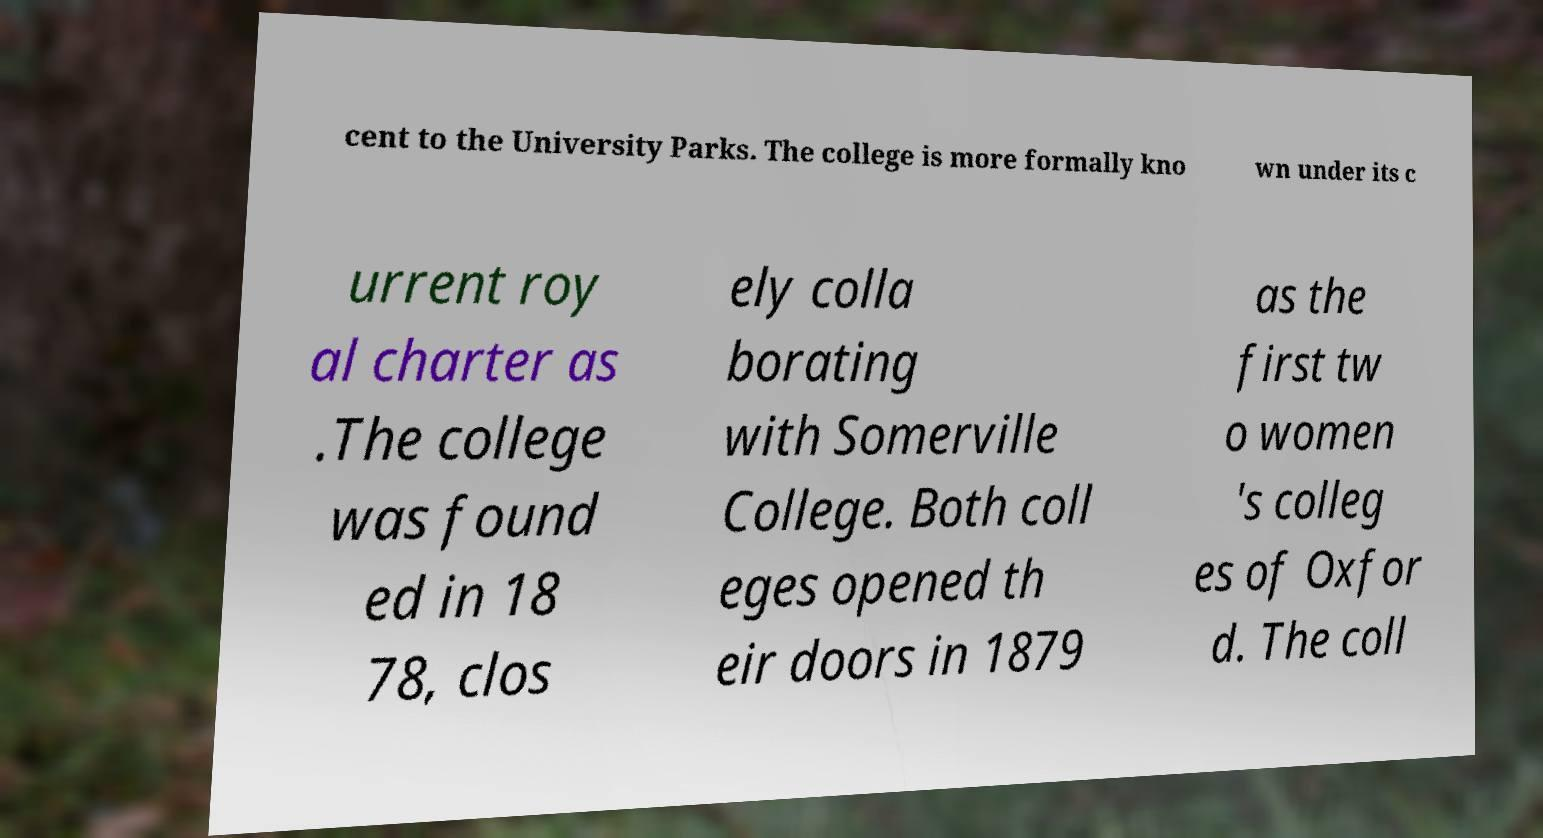I need the written content from this picture converted into text. Can you do that? cent to the University Parks. The college is more formally kno wn under its c urrent roy al charter as .The college was found ed in 18 78, clos ely colla borating with Somerville College. Both coll eges opened th eir doors in 1879 as the first tw o women 's colleg es of Oxfor d. The coll 